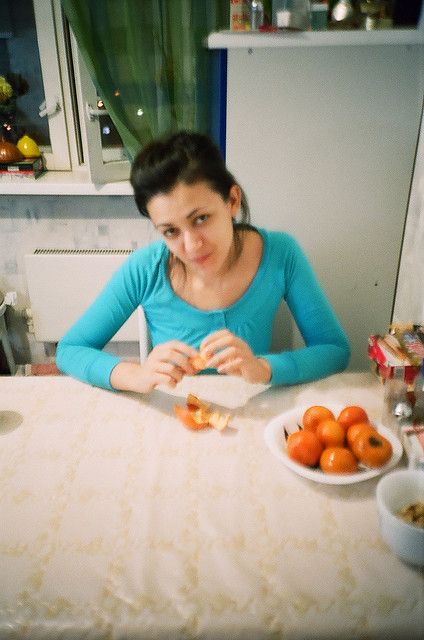<image>What vegetable is on the table? I am not sure what vegetable is on the table. It can be tomatoes or persimmons. What are the white objects in the bowl? It is unknown what the white objects in the bowl are. It could be anything from orange peel, nuts, chips to tomatoes or even bananas. What vegetable is on the table? I am not sure what vegetable is on the table. It can be seen tomatoes, tomato or persimmon. What are the white objects in the bowl? I am not sure what are the white objects in the bowl. It can be seen orange peel, nuts, chips or tomatoes. 